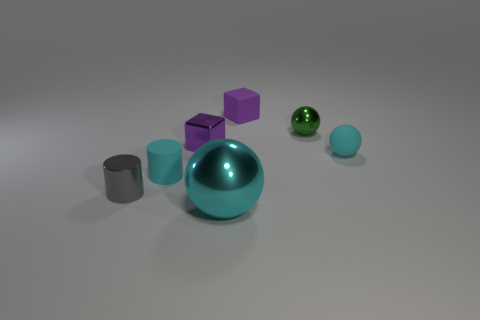What size is the purple metal thing that is the same shape as the small purple rubber thing?
Ensure brevity in your answer.  Small. How many things are both in front of the tiny gray metal thing and behind the green object?
Provide a succinct answer. 0. Is the shape of the small purple rubber object the same as the small cyan matte object that is to the left of the tiny green thing?
Keep it short and to the point. No. Are there more shiny cubes that are behind the small purple metallic cube than small cylinders?
Offer a terse response. No. Is the number of cyan matte cylinders behind the shiny cylinder less than the number of green shiny spheres?
Provide a succinct answer. No. What number of rubber balls are the same color as the tiny shiny sphere?
Provide a succinct answer. 0. What material is the thing that is both on the left side of the small metallic ball and right of the large thing?
Offer a terse response. Rubber. There is a rubber cylinder that is on the left side of the small shiny cube; is its color the same as the ball in front of the small cyan rubber ball?
Ensure brevity in your answer.  Yes. What number of yellow objects are either small cylinders or small blocks?
Make the answer very short. 0. Is the number of gray metallic objects on the right side of the purple metallic object less than the number of large cyan spheres that are left of the gray shiny thing?
Offer a very short reply. No. 